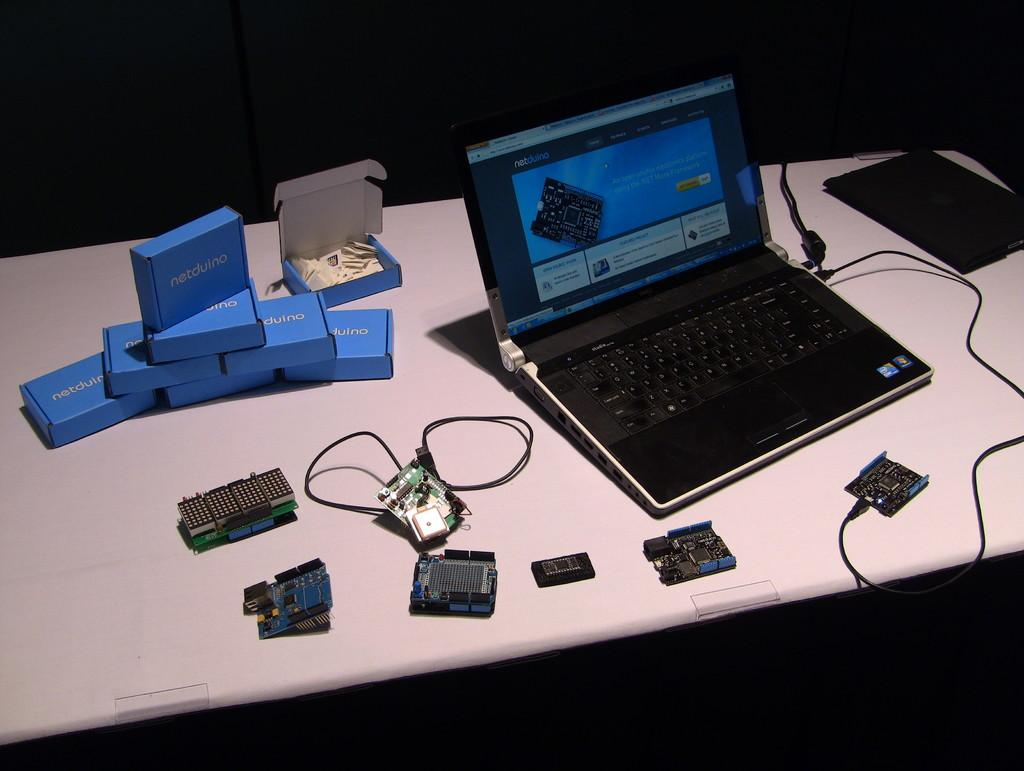<image>
Render a clear and concise summary of the photo. A laptop that has opened a web page about circuit boards . 